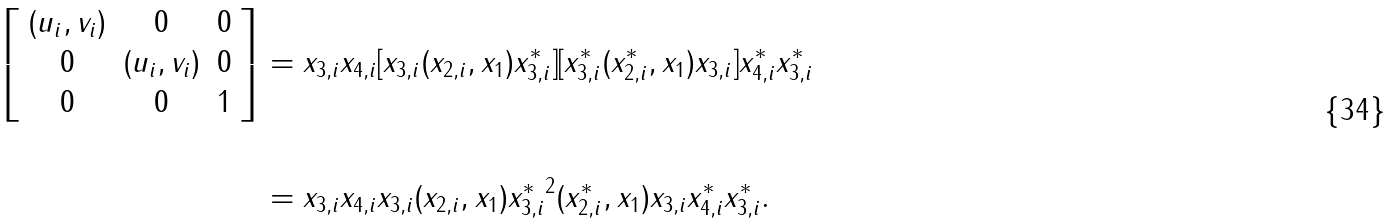Convert formula to latex. <formula><loc_0><loc_0><loc_500><loc_500>\left [ \begin{array} { c c c } ( u _ { i } , v _ { i } ) & 0 & 0 \\ 0 & ( u _ { i } , v _ { i } ) & 0 \\ 0 & 0 & 1 \end{array} \right ] & = x _ { 3 , i } x _ { 4 , i } [ x _ { 3 , i } ( x _ { 2 , i } , x _ { 1 } ) x _ { 3 , i } ^ { * } ] [ x _ { 3 , i } ^ { * } ( x _ { 2 , i } ^ { * } , x _ { 1 } ) x _ { 3 , i } ] x _ { 4 , i } ^ { * } x _ { 3 , i } ^ { * } \\ \\ & = x _ { 3 , i } x _ { 4 , i } x _ { 3 , i } ( x _ { 2 , i } , x _ { 1 } ) { x _ { 3 , i } ^ { * } } ^ { 2 } ( x _ { 2 , i } ^ { * } , x _ { 1 } ) x _ { 3 , i } x _ { 4 , i } ^ { * } x _ { 3 , i } ^ { * } .</formula> 